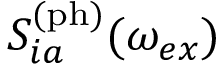Convert formula to latex. <formula><loc_0><loc_0><loc_500><loc_500>S _ { i a } ^ { ( p h ) } ( \omega _ { e x } )</formula> 